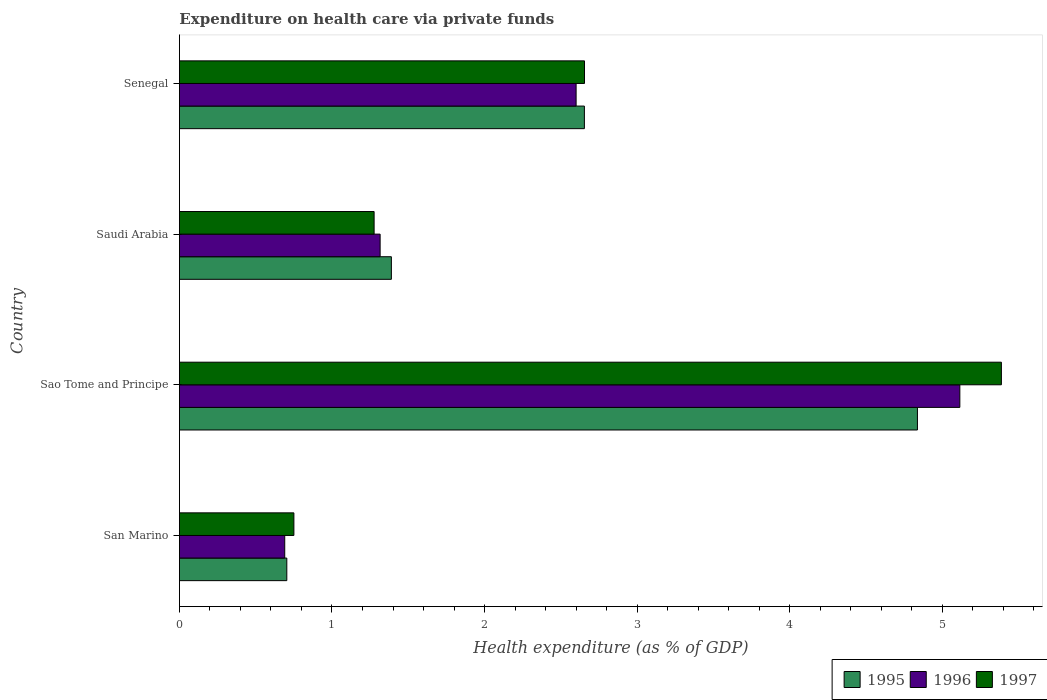How many different coloured bars are there?
Ensure brevity in your answer.  3. How many groups of bars are there?
Keep it short and to the point. 4. Are the number of bars per tick equal to the number of legend labels?
Make the answer very short. Yes. Are the number of bars on each tick of the Y-axis equal?
Your answer should be very brief. Yes. How many bars are there on the 1st tick from the bottom?
Offer a very short reply. 3. What is the label of the 2nd group of bars from the top?
Provide a short and direct response. Saudi Arabia. In how many cases, is the number of bars for a given country not equal to the number of legend labels?
Offer a very short reply. 0. What is the expenditure made on health care in 1997 in San Marino?
Offer a terse response. 0.75. Across all countries, what is the maximum expenditure made on health care in 1996?
Keep it short and to the point. 5.12. Across all countries, what is the minimum expenditure made on health care in 1996?
Keep it short and to the point. 0.69. In which country was the expenditure made on health care in 1996 maximum?
Your answer should be very brief. Sao Tome and Principe. In which country was the expenditure made on health care in 1996 minimum?
Your answer should be very brief. San Marino. What is the total expenditure made on health care in 1996 in the graph?
Offer a terse response. 9.72. What is the difference between the expenditure made on health care in 1995 in San Marino and that in Sao Tome and Principe?
Give a very brief answer. -4.13. What is the difference between the expenditure made on health care in 1996 in Saudi Arabia and the expenditure made on health care in 1997 in Sao Tome and Principe?
Your answer should be compact. -4.07. What is the average expenditure made on health care in 1997 per country?
Make the answer very short. 2.52. What is the difference between the expenditure made on health care in 1995 and expenditure made on health care in 1996 in Senegal?
Offer a very short reply. 0.05. In how many countries, is the expenditure made on health care in 1995 greater than 3.4 %?
Offer a very short reply. 1. What is the ratio of the expenditure made on health care in 1997 in San Marino to that in Senegal?
Your response must be concise. 0.28. Is the expenditure made on health care in 1995 in San Marino less than that in Sao Tome and Principe?
Give a very brief answer. Yes. What is the difference between the highest and the second highest expenditure made on health care in 1995?
Offer a very short reply. 2.18. What is the difference between the highest and the lowest expenditure made on health care in 1996?
Offer a terse response. 4.43. Is the sum of the expenditure made on health care in 1997 in San Marino and Saudi Arabia greater than the maximum expenditure made on health care in 1995 across all countries?
Give a very brief answer. No. What does the 3rd bar from the top in Saudi Arabia represents?
Give a very brief answer. 1995. What does the 2nd bar from the bottom in Sao Tome and Principe represents?
Give a very brief answer. 1996. How many bars are there?
Offer a very short reply. 12. What is the difference between two consecutive major ticks on the X-axis?
Your response must be concise. 1. Are the values on the major ticks of X-axis written in scientific E-notation?
Keep it short and to the point. No. Does the graph contain any zero values?
Offer a very short reply. No. Does the graph contain grids?
Offer a terse response. No. Where does the legend appear in the graph?
Offer a very short reply. Bottom right. How are the legend labels stacked?
Offer a terse response. Horizontal. What is the title of the graph?
Your answer should be very brief. Expenditure on health care via private funds. Does "1968" appear as one of the legend labels in the graph?
Your response must be concise. No. What is the label or title of the X-axis?
Your response must be concise. Health expenditure (as % of GDP). What is the Health expenditure (as % of GDP) of 1995 in San Marino?
Offer a very short reply. 0.7. What is the Health expenditure (as % of GDP) in 1996 in San Marino?
Give a very brief answer. 0.69. What is the Health expenditure (as % of GDP) of 1997 in San Marino?
Your answer should be very brief. 0.75. What is the Health expenditure (as % of GDP) in 1995 in Sao Tome and Principe?
Give a very brief answer. 4.84. What is the Health expenditure (as % of GDP) in 1996 in Sao Tome and Principe?
Your response must be concise. 5.12. What is the Health expenditure (as % of GDP) in 1997 in Sao Tome and Principe?
Provide a succinct answer. 5.39. What is the Health expenditure (as % of GDP) in 1995 in Saudi Arabia?
Offer a terse response. 1.39. What is the Health expenditure (as % of GDP) of 1996 in Saudi Arabia?
Ensure brevity in your answer.  1.32. What is the Health expenditure (as % of GDP) of 1997 in Saudi Arabia?
Your answer should be very brief. 1.28. What is the Health expenditure (as % of GDP) of 1995 in Senegal?
Keep it short and to the point. 2.65. What is the Health expenditure (as % of GDP) of 1996 in Senegal?
Provide a short and direct response. 2.6. What is the Health expenditure (as % of GDP) in 1997 in Senegal?
Give a very brief answer. 2.66. Across all countries, what is the maximum Health expenditure (as % of GDP) of 1995?
Provide a succinct answer. 4.84. Across all countries, what is the maximum Health expenditure (as % of GDP) of 1996?
Your answer should be compact. 5.12. Across all countries, what is the maximum Health expenditure (as % of GDP) of 1997?
Provide a short and direct response. 5.39. Across all countries, what is the minimum Health expenditure (as % of GDP) of 1995?
Your answer should be very brief. 0.7. Across all countries, what is the minimum Health expenditure (as % of GDP) in 1996?
Provide a succinct answer. 0.69. Across all countries, what is the minimum Health expenditure (as % of GDP) in 1997?
Your answer should be very brief. 0.75. What is the total Health expenditure (as % of GDP) in 1995 in the graph?
Give a very brief answer. 9.59. What is the total Health expenditure (as % of GDP) in 1996 in the graph?
Your answer should be very brief. 9.72. What is the total Health expenditure (as % of GDP) in 1997 in the graph?
Offer a very short reply. 10.07. What is the difference between the Health expenditure (as % of GDP) of 1995 in San Marino and that in Sao Tome and Principe?
Your response must be concise. -4.13. What is the difference between the Health expenditure (as % of GDP) in 1996 in San Marino and that in Sao Tome and Principe?
Ensure brevity in your answer.  -4.43. What is the difference between the Health expenditure (as % of GDP) of 1997 in San Marino and that in Sao Tome and Principe?
Ensure brevity in your answer.  -4.64. What is the difference between the Health expenditure (as % of GDP) in 1995 in San Marino and that in Saudi Arabia?
Keep it short and to the point. -0.69. What is the difference between the Health expenditure (as % of GDP) in 1996 in San Marino and that in Saudi Arabia?
Provide a short and direct response. -0.63. What is the difference between the Health expenditure (as % of GDP) in 1997 in San Marino and that in Saudi Arabia?
Provide a short and direct response. -0.53. What is the difference between the Health expenditure (as % of GDP) of 1995 in San Marino and that in Senegal?
Your answer should be very brief. -1.95. What is the difference between the Health expenditure (as % of GDP) of 1996 in San Marino and that in Senegal?
Your answer should be compact. -1.91. What is the difference between the Health expenditure (as % of GDP) of 1997 in San Marino and that in Senegal?
Your answer should be compact. -1.9. What is the difference between the Health expenditure (as % of GDP) of 1995 in Sao Tome and Principe and that in Saudi Arabia?
Provide a short and direct response. 3.45. What is the difference between the Health expenditure (as % of GDP) of 1997 in Sao Tome and Principe and that in Saudi Arabia?
Offer a very short reply. 4.11. What is the difference between the Health expenditure (as % of GDP) in 1995 in Sao Tome and Principe and that in Senegal?
Offer a very short reply. 2.18. What is the difference between the Health expenditure (as % of GDP) in 1996 in Sao Tome and Principe and that in Senegal?
Keep it short and to the point. 2.52. What is the difference between the Health expenditure (as % of GDP) in 1997 in Sao Tome and Principe and that in Senegal?
Make the answer very short. 2.73. What is the difference between the Health expenditure (as % of GDP) of 1995 in Saudi Arabia and that in Senegal?
Ensure brevity in your answer.  -1.27. What is the difference between the Health expenditure (as % of GDP) of 1996 in Saudi Arabia and that in Senegal?
Make the answer very short. -1.28. What is the difference between the Health expenditure (as % of GDP) in 1997 in Saudi Arabia and that in Senegal?
Make the answer very short. -1.38. What is the difference between the Health expenditure (as % of GDP) of 1995 in San Marino and the Health expenditure (as % of GDP) of 1996 in Sao Tome and Principe?
Provide a short and direct response. -4.41. What is the difference between the Health expenditure (as % of GDP) of 1995 in San Marino and the Health expenditure (as % of GDP) of 1997 in Sao Tome and Principe?
Make the answer very short. -4.68. What is the difference between the Health expenditure (as % of GDP) in 1996 in San Marino and the Health expenditure (as % of GDP) in 1997 in Sao Tome and Principe?
Your response must be concise. -4.7. What is the difference between the Health expenditure (as % of GDP) of 1995 in San Marino and the Health expenditure (as % of GDP) of 1996 in Saudi Arabia?
Your answer should be compact. -0.61. What is the difference between the Health expenditure (as % of GDP) of 1995 in San Marino and the Health expenditure (as % of GDP) of 1997 in Saudi Arabia?
Give a very brief answer. -0.57. What is the difference between the Health expenditure (as % of GDP) of 1996 in San Marino and the Health expenditure (as % of GDP) of 1997 in Saudi Arabia?
Provide a short and direct response. -0.59. What is the difference between the Health expenditure (as % of GDP) of 1995 in San Marino and the Health expenditure (as % of GDP) of 1996 in Senegal?
Your answer should be compact. -1.9. What is the difference between the Health expenditure (as % of GDP) in 1995 in San Marino and the Health expenditure (as % of GDP) in 1997 in Senegal?
Provide a succinct answer. -1.95. What is the difference between the Health expenditure (as % of GDP) of 1996 in San Marino and the Health expenditure (as % of GDP) of 1997 in Senegal?
Ensure brevity in your answer.  -1.97. What is the difference between the Health expenditure (as % of GDP) in 1995 in Sao Tome and Principe and the Health expenditure (as % of GDP) in 1996 in Saudi Arabia?
Your response must be concise. 3.52. What is the difference between the Health expenditure (as % of GDP) in 1995 in Sao Tome and Principe and the Health expenditure (as % of GDP) in 1997 in Saudi Arabia?
Offer a terse response. 3.56. What is the difference between the Health expenditure (as % of GDP) of 1996 in Sao Tome and Principe and the Health expenditure (as % of GDP) of 1997 in Saudi Arabia?
Ensure brevity in your answer.  3.84. What is the difference between the Health expenditure (as % of GDP) in 1995 in Sao Tome and Principe and the Health expenditure (as % of GDP) in 1996 in Senegal?
Provide a short and direct response. 2.24. What is the difference between the Health expenditure (as % of GDP) in 1995 in Sao Tome and Principe and the Health expenditure (as % of GDP) in 1997 in Senegal?
Your answer should be very brief. 2.18. What is the difference between the Health expenditure (as % of GDP) in 1996 in Sao Tome and Principe and the Health expenditure (as % of GDP) in 1997 in Senegal?
Offer a terse response. 2.46. What is the difference between the Health expenditure (as % of GDP) in 1995 in Saudi Arabia and the Health expenditure (as % of GDP) in 1996 in Senegal?
Give a very brief answer. -1.21. What is the difference between the Health expenditure (as % of GDP) in 1995 in Saudi Arabia and the Health expenditure (as % of GDP) in 1997 in Senegal?
Keep it short and to the point. -1.27. What is the difference between the Health expenditure (as % of GDP) of 1996 in Saudi Arabia and the Health expenditure (as % of GDP) of 1997 in Senegal?
Make the answer very short. -1.34. What is the average Health expenditure (as % of GDP) of 1995 per country?
Provide a short and direct response. 2.4. What is the average Health expenditure (as % of GDP) of 1996 per country?
Your response must be concise. 2.43. What is the average Health expenditure (as % of GDP) in 1997 per country?
Offer a terse response. 2.52. What is the difference between the Health expenditure (as % of GDP) in 1995 and Health expenditure (as % of GDP) in 1996 in San Marino?
Your response must be concise. 0.01. What is the difference between the Health expenditure (as % of GDP) of 1995 and Health expenditure (as % of GDP) of 1997 in San Marino?
Offer a very short reply. -0.05. What is the difference between the Health expenditure (as % of GDP) of 1996 and Health expenditure (as % of GDP) of 1997 in San Marino?
Your response must be concise. -0.06. What is the difference between the Health expenditure (as % of GDP) of 1995 and Health expenditure (as % of GDP) of 1996 in Sao Tome and Principe?
Your answer should be very brief. -0.28. What is the difference between the Health expenditure (as % of GDP) of 1995 and Health expenditure (as % of GDP) of 1997 in Sao Tome and Principe?
Give a very brief answer. -0.55. What is the difference between the Health expenditure (as % of GDP) in 1996 and Health expenditure (as % of GDP) in 1997 in Sao Tome and Principe?
Make the answer very short. -0.27. What is the difference between the Health expenditure (as % of GDP) of 1995 and Health expenditure (as % of GDP) of 1996 in Saudi Arabia?
Provide a succinct answer. 0.07. What is the difference between the Health expenditure (as % of GDP) in 1995 and Health expenditure (as % of GDP) in 1997 in Saudi Arabia?
Provide a succinct answer. 0.11. What is the difference between the Health expenditure (as % of GDP) of 1996 and Health expenditure (as % of GDP) of 1997 in Saudi Arabia?
Your answer should be compact. 0.04. What is the difference between the Health expenditure (as % of GDP) in 1995 and Health expenditure (as % of GDP) in 1996 in Senegal?
Ensure brevity in your answer.  0.05. What is the difference between the Health expenditure (as % of GDP) of 1995 and Health expenditure (as % of GDP) of 1997 in Senegal?
Provide a short and direct response. -0. What is the difference between the Health expenditure (as % of GDP) of 1996 and Health expenditure (as % of GDP) of 1997 in Senegal?
Your answer should be compact. -0.06. What is the ratio of the Health expenditure (as % of GDP) in 1995 in San Marino to that in Sao Tome and Principe?
Your answer should be compact. 0.15. What is the ratio of the Health expenditure (as % of GDP) in 1996 in San Marino to that in Sao Tome and Principe?
Your answer should be compact. 0.13. What is the ratio of the Health expenditure (as % of GDP) of 1997 in San Marino to that in Sao Tome and Principe?
Your answer should be very brief. 0.14. What is the ratio of the Health expenditure (as % of GDP) of 1995 in San Marino to that in Saudi Arabia?
Give a very brief answer. 0.51. What is the ratio of the Health expenditure (as % of GDP) of 1996 in San Marino to that in Saudi Arabia?
Your answer should be very brief. 0.52. What is the ratio of the Health expenditure (as % of GDP) in 1997 in San Marino to that in Saudi Arabia?
Provide a succinct answer. 0.59. What is the ratio of the Health expenditure (as % of GDP) of 1995 in San Marino to that in Senegal?
Provide a succinct answer. 0.27. What is the ratio of the Health expenditure (as % of GDP) in 1996 in San Marino to that in Senegal?
Offer a terse response. 0.27. What is the ratio of the Health expenditure (as % of GDP) of 1997 in San Marino to that in Senegal?
Offer a terse response. 0.28. What is the ratio of the Health expenditure (as % of GDP) of 1995 in Sao Tome and Principe to that in Saudi Arabia?
Make the answer very short. 3.48. What is the ratio of the Health expenditure (as % of GDP) of 1996 in Sao Tome and Principe to that in Saudi Arabia?
Provide a succinct answer. 3.89. What is the ratio of the Health expenditure (as % of GDP) of 1997 in Sao Tome and Principe to that in Saudi Arabia?
Give a very brief answer. 4.22. What is the ratio of the Health expenditure (as % of GDP) of 1995 in Sao Tome and Principe to that in Senegal?
Provide a succinct answer. 1.82. What is the ratio of the Health expenditure (as % of GDP) of 1996 in Sao Tome and Principe to that in Senegal?
Your response must be concise. 1.97. What is the ratio of the Health expenditure (as % of GDP) in 1997 in Sao Tome and Principe to that in Senegal?
Your answer should be compact. 2.03. What is the ratio of the Health expenditure (as % of GDP) of 1995 in Saudi Arabia to that in Senegal?
Ensure brevity in your answer.  0.52. What is the ratio of the Health expenditure (as % of GDP) in 1996 in Saudi Arabia to that in Senegal?
Your response must be concise. 0.51. What is the ratio of the Health expenditure (as % of GDP) of 1997 in Saudi Arabia to that in Senegal?
Your response must be concise. 0.48. What is the difference between the highest and the second highest Health expenditure (as % of GDP) of 1995?
Make the answer very short. 2.18. What is the difference between the highest and the second highest Health expenditure (as % of GDP) in 1996?
Give a very brief answer. 2.52. What is the difference between the highest and the second highest Health expenditure (as % of GDP) of 1997?
Your answer should be very brief. 2.73. What is the difference between the highest and the lowest Health expenditure (as % of GDP) in 1995?
Keep it short and to the point. 4.13. What is the difference between the highest and the lowest Health expenditure (as % of GDP) of 1996?
Offer a terse response. 4.43. What is the difference between the highest and the lowest Health expenditure (as % of GDP) in 1997?
Your answer should be compact. 4.64. 